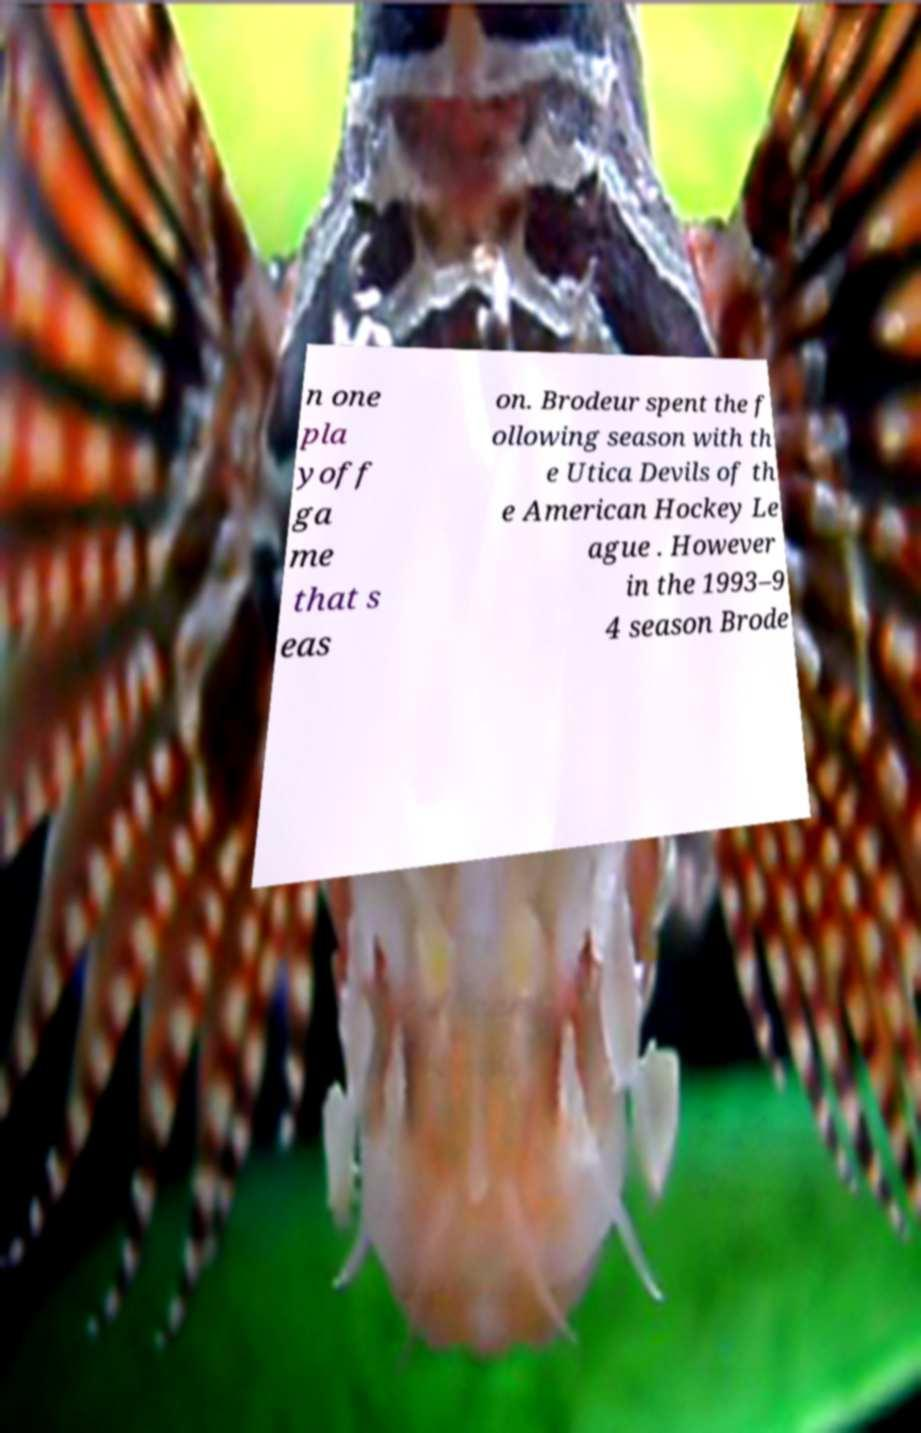Can you accurately transcribe the text from the provided image for me? n one pla yoff ga me that s eas on. Brodeur spent the f ollowing season with th e Utica Devils of th e American Hockey Le ague . However in the 1993–9 4 season Brode 